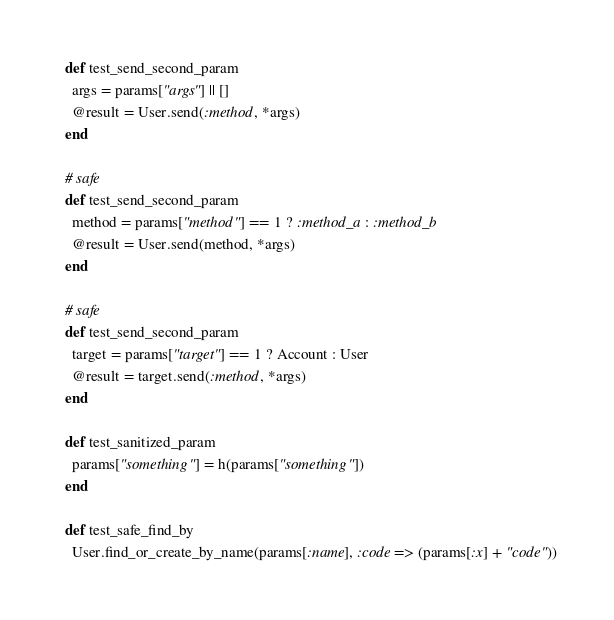<code> <loc_0><loc_0><loc_500><loc_500><_Ruby_>  def test_send_second_param
    args = params["args"] || []
    @result = User.send(:method, *args)
  end

  # safe
  def test_send_second_param
    method = params["method"] == 1 ? :method_a : :method_b
    @result = User.send(method, *args)
  end

  # safe
  def test_send_second_param
    target = params["target"] == 1 ? Account : User
    @result = target.send(:method, *args)
  end

  def test_sanitized_param
    params["something"] = h(params["something"])
  end

  def test_safe_find_by
    User.find_or_create_by_name(params[:name], :code => (params[:x] + "code"))</code> 